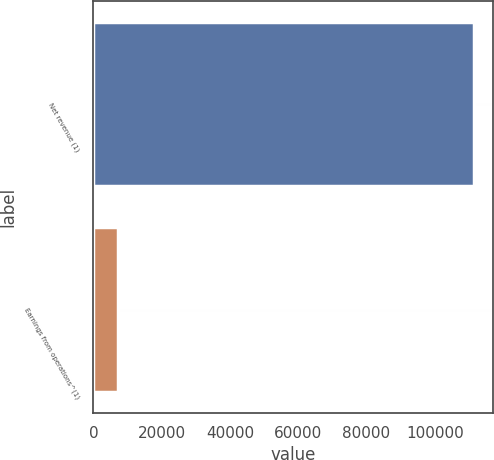<chart> <loc_0><loc_0><loc_500><loc_500><bar_chart><fcel>Net revenue (1)<fcel>Earnings from operations^(1)<nl><fcel>111454<fcel>7185<nl></chart> 